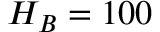<formula> <loc_0><loc_0><loc_500><loc_500>H _ { B } = 1 0 0</formula> 